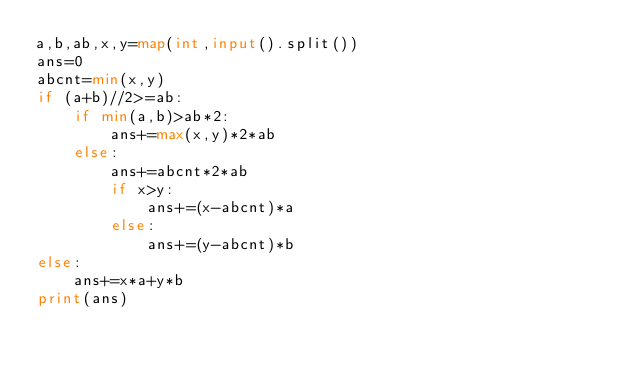Convert code to text. <code><loc_0><loc_0><loc_500><loc_500><_Python_>a,b,ab,x,y=map(int,input().split())
ans=0
abcnt=min(x,y)
if (a+b)//2>=ab:
    if min(a,b)>ab*2:
        ans+=max(x,y)*2*ab
    else:
        ans+=abcnt*2*ab
        if x>y:
            ans+=(x-abcnt)*a
        else:
            ans+=(y-abcnt)*b
else:
    ans+=x*a+y*b
print(ans)
</code> 